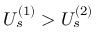<formula> <loc_0><loc_0><loc_500><loc_500>U _ { s } ^ { ( 1 ) } > U _ { s } ^ { ( 2 ) }</formula> 